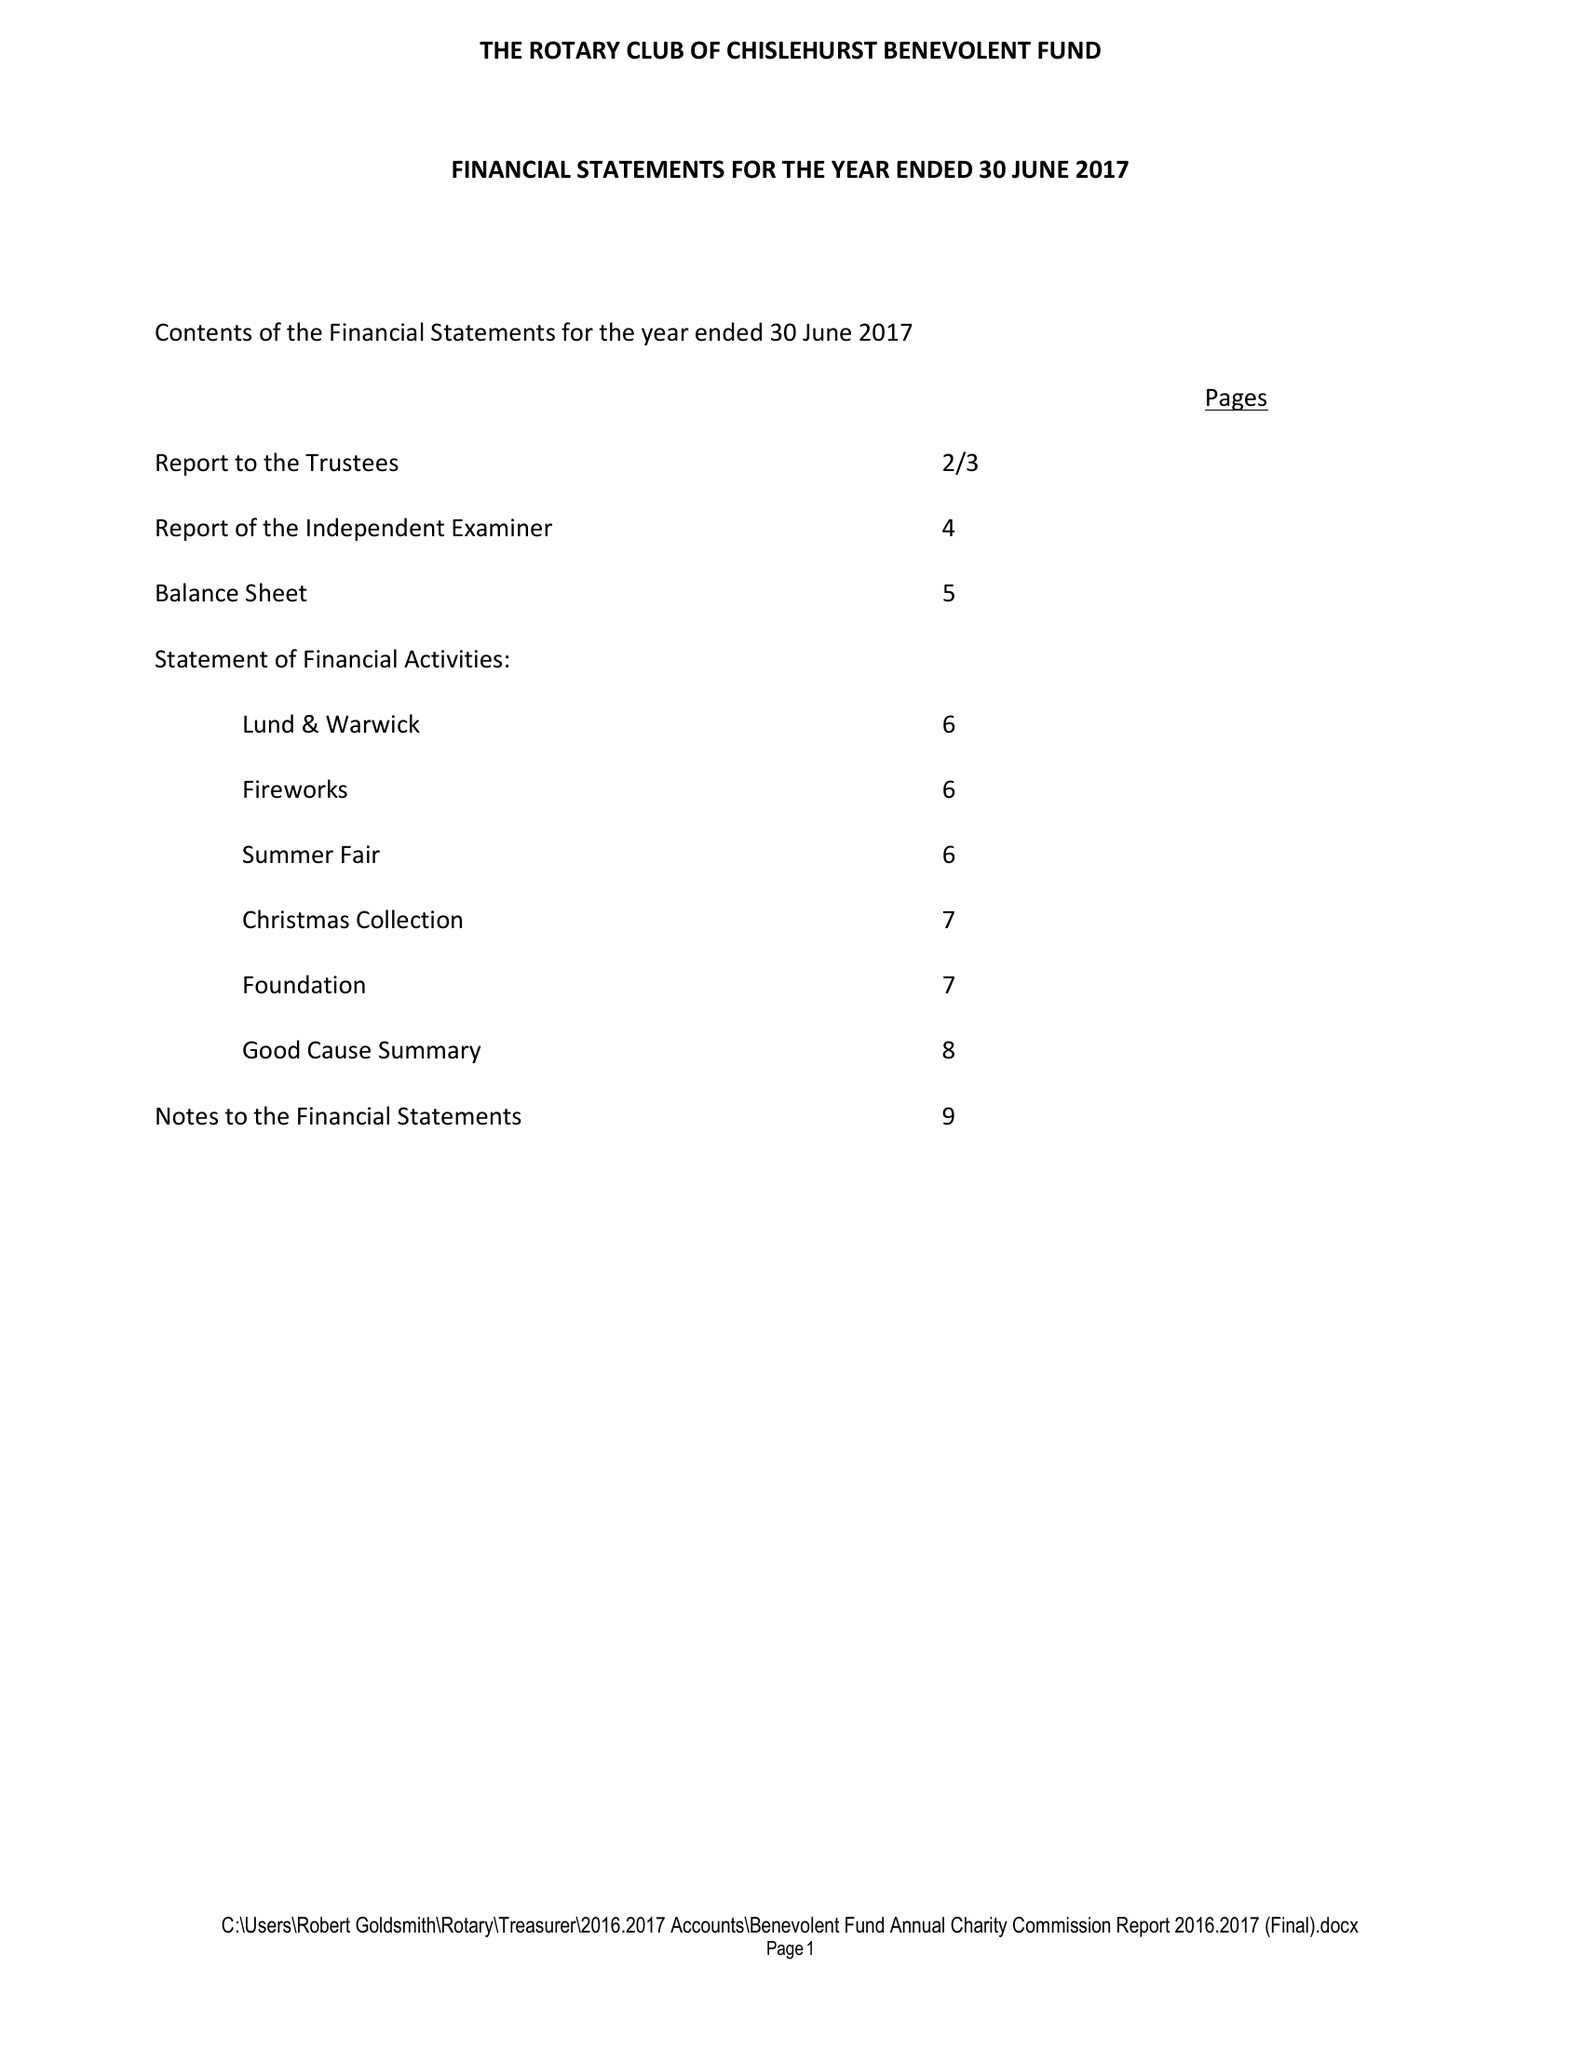What is the value for the address__post_town?
Answer the question using a single word or phrase. ORPINGTON 